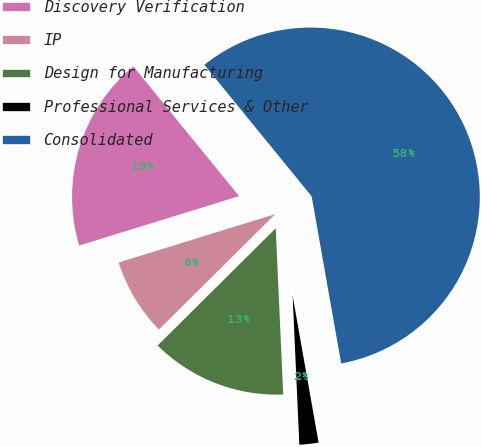<chart> <loc_0><loc_0><loc_500><loc_500><pie_chart><fcel>Discovery Verification<fcel>IP<fcel>Design for Manufacturing<fcel>Professional Services & Other<fcel>Consolidated<nl><fcel>18.88%<fcel>7.67%<fcel>13.28%<fcel>2.07%<fcel>58.11%<nl></chart> 